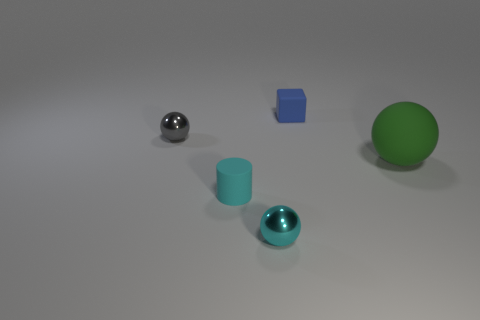Add 3 small rubber cylinders. How many objects exist? 8 Subtract all cylinders. How many objects are left? 4 Subtract 0 yellow cylinders. How many objects are left? 5 Subtract all blue cubes. Subtract all tiny rubber blocks. How many objects are left? 3 Add 5 gray things. How many gray things are left? 6 Add 3 cyan rubber things. How many cyan rubber things exist? 4 